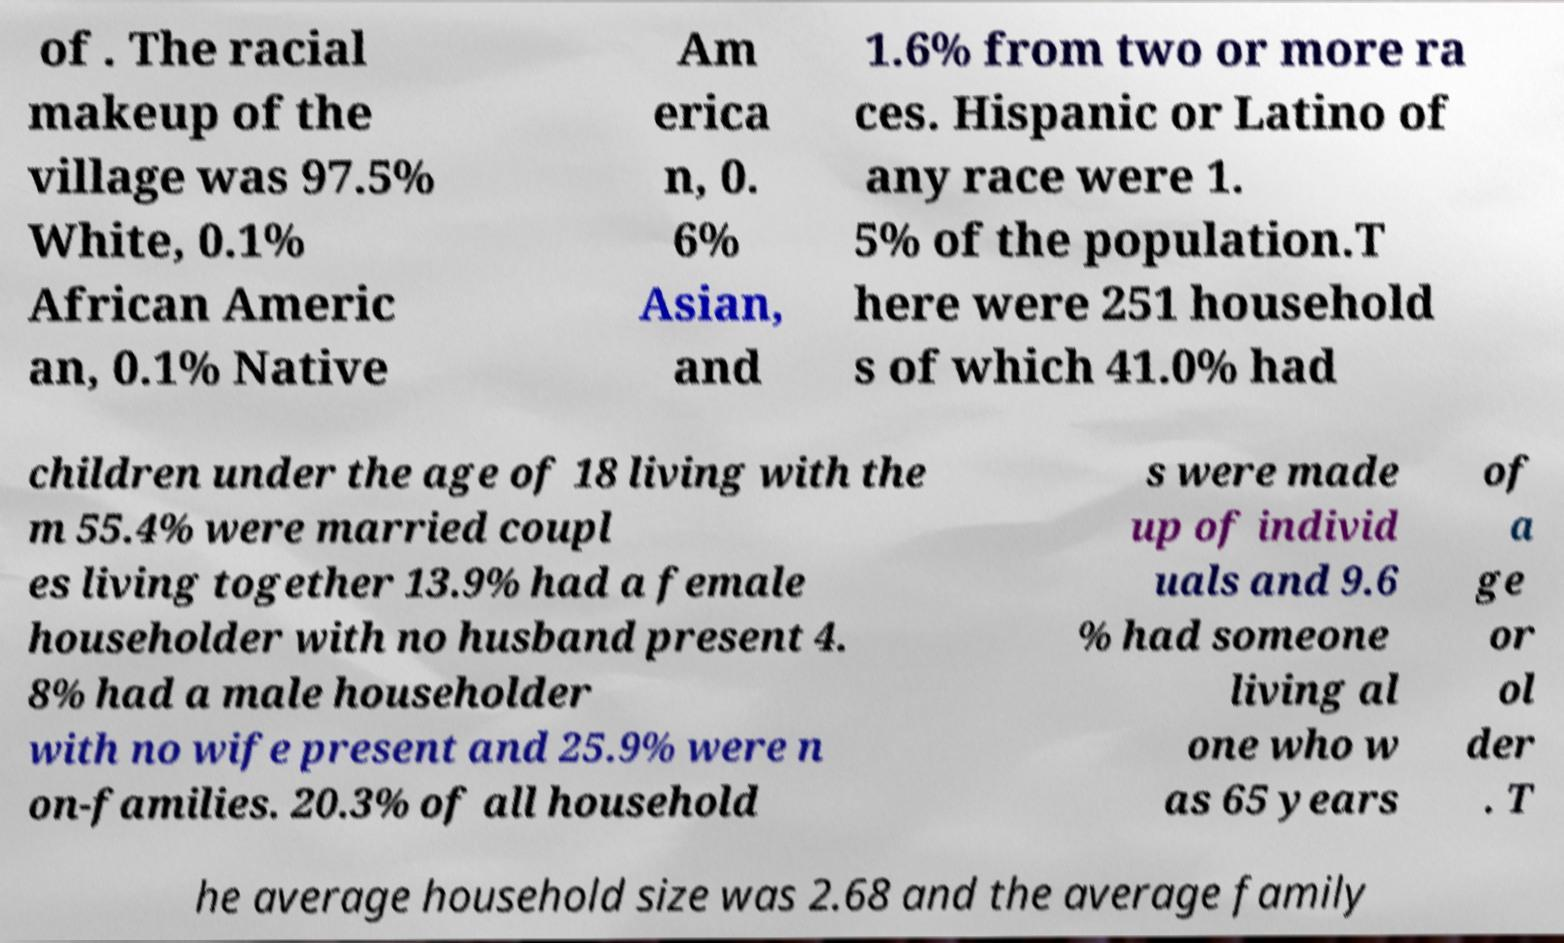Can you accurately transcribe the text from the provided image for me? of . The racial makeup of the village was 97.5% White, 0.1% African Americ an, 0.1% Native Am erica n, 0. 6% Asian, and 1.6% from two or more ra ces. Hispanic or Latino of any race were 1. 5% of the population.T here were 251 household s of which 41.0% had children under the age of 18 living with the m 55.4% were married coupl es living together 13.9% had a female householder with no husband present 4. 8% had a male householder with no wife present and 25.9% were n on-families. 20.3% of all household s were made up of individ uals and 9.6 % had someone living al one who w as 65 years of a ge or ol der . T he average household size was 2.68 and the average family 